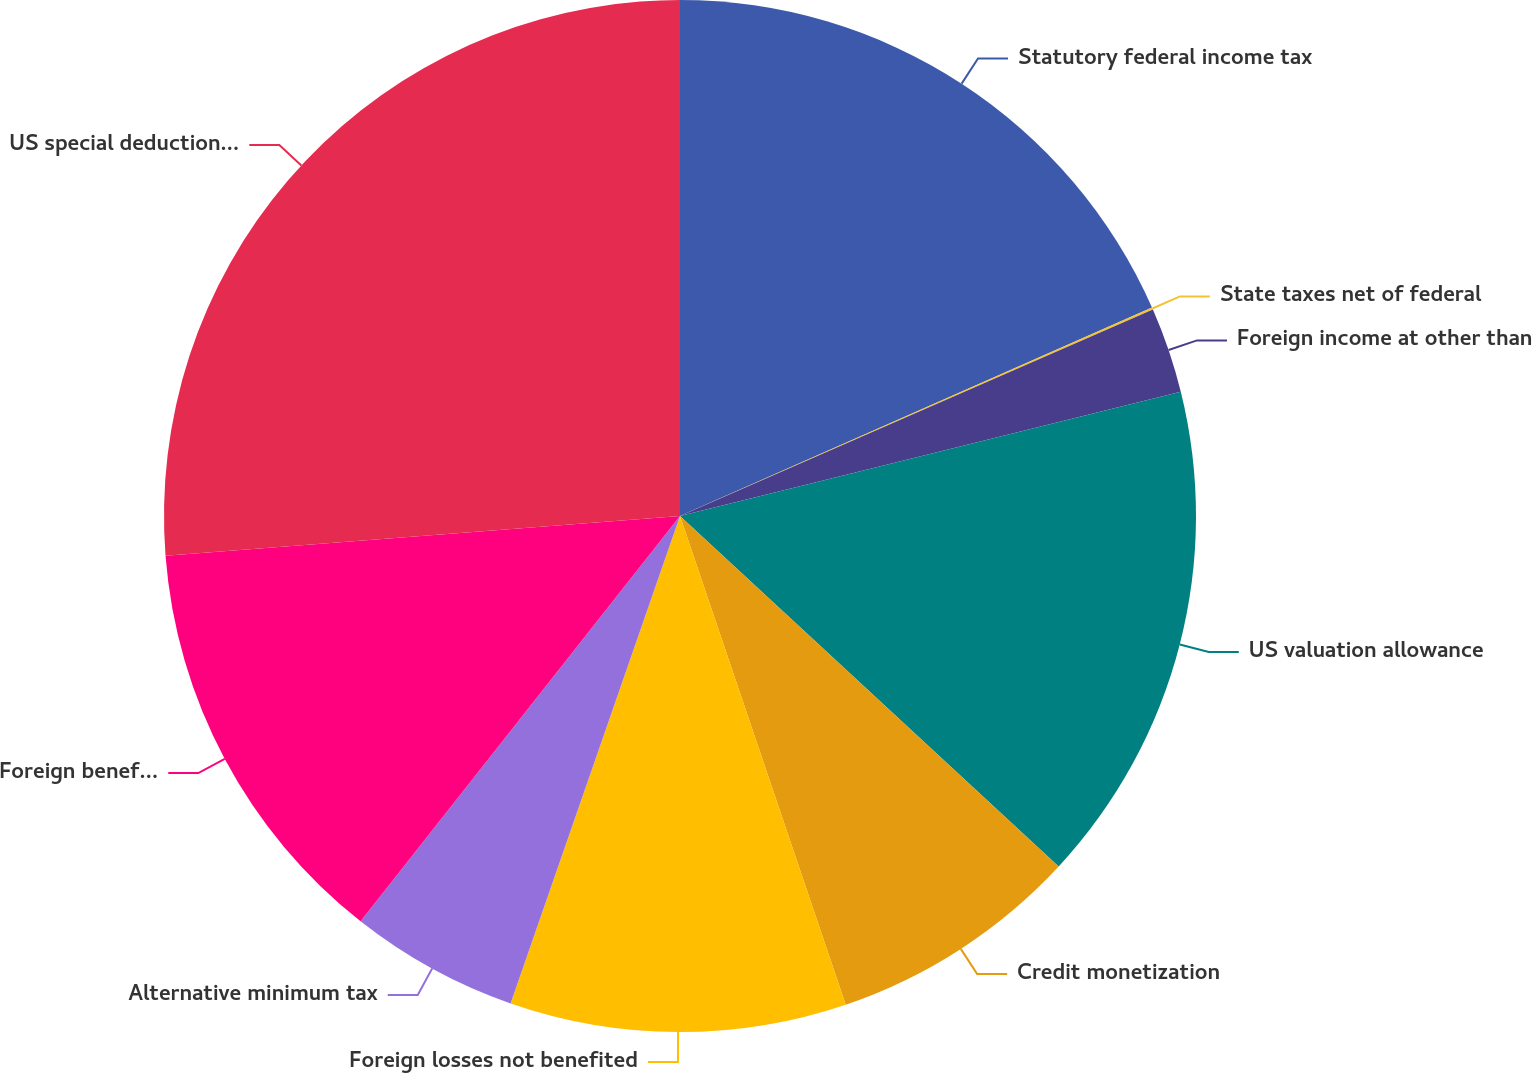Convert chart to OTSL. <chart><loc_0><loc_0><loc_500><loc_500><pie_chart><fcel>Statutory federal income tax<fcel>State taxes net of federal<fcel>Foreign income at other than<fcel>US valuation allowance<fcel>Credit monetization<fcel>Foreign losses not benefited<fcel>Alternative minimum tax<fcel>Foreign benefits not realized<fcel>US special deduction under IRC<nl><fcel>18.38%<fcel>0.07%<fcel>2.68%<fcel>15.76%<fcel>7.91%<fcel>10.53%<fcel>5.3%<fcel>13.15%<fcel>26.23%<nl></chart> 